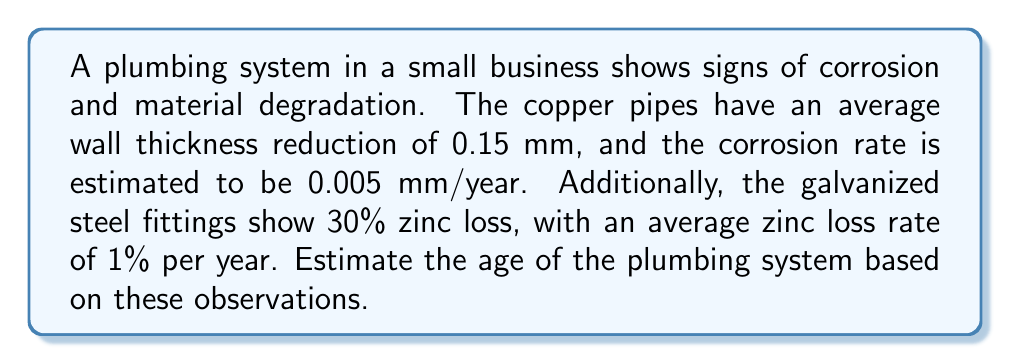What is the answer to this math problem? To estimate the age of the plumbing system, we'll use the inverse problem approach with the given information about corrosion and material degradation. We'll calculate the age based on both copper pipes and galvanized steel fittings, then compare the results.

1. Age estimation based on copper pipes:
   Let $t_c$ be the age of the copper pipes in years.
   $$t_c = \frac{\text{Thickness reduction}}{\text{Corrosion rate}}$$
   $$t_c = \frac{0.15 \text{ mm}}{0.005 \text{ mm/year}} = 30 \text{ years}$$

2. Age estimation based on galvanized steel fittings:
   Let $t_g$ be the age of the galvanized steel fittings in years.
   $$t_g = \frac{\text{Zinc loss percentage}}{\text{Zinc loss rate per year}}$$
   $$t_g = \frac{30\%}{1\% \text{ per year}} = 30 \text{ years}$$

3. Compare the results:
   Both estimations yield the same result of 30 years, which increases our confidence in the estimate.

4. Conclusion:
   Based on the corrosion patterns and material degradation observed in both the copper pipes and galvanized steel fittings, we can estimate that the plumbing system is approximately 30 years old.
Answer: 30 years 